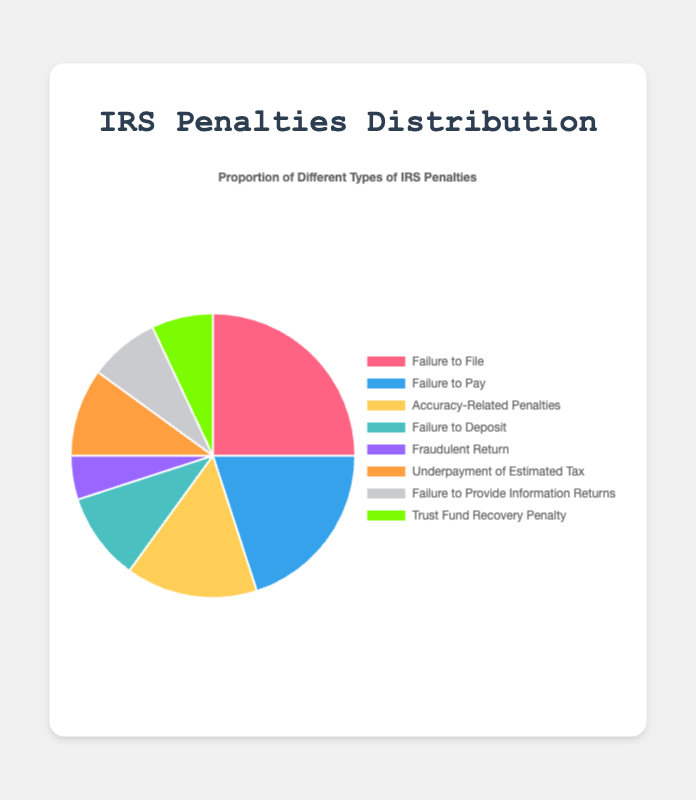Which penalty type has the highest proportion? The penalty type with the highest proportion can be identified as the largest segment in the pie chart. "Failure to File" has the highest proportion as its segment is 25% of the pie.
Answer: Failure to File Which penalty type has the smallest proportion? The penalty type with the smallest proportion is the one with the smallest segment in the pie chart. "Fraudulent Return" has the smallest proportion, making up only 5% of the pie.
Answer: Fraudulent Return What is the sum of the proportions of "Failure to Pay" and "Underpayment of Estimated Tax"? To get the sum, we add the proportions of "Failure to Pay" (20%) and "Underpayment of Estimated Tax" (10%). 20 + 10 = 30.
Answer: 30% How much greater is the proportion of "Failure to File" compared to "Failure to Deposit"? The difference between the proportions is calculated by subtracting the proportion of "Failure to Deposit" (10%) from "Failure to File" (25%). 25 - 10 = 15
Answer: 15% Which penalty types have equal proportions, and what are those proportions? By examining the chart, we see that "Failure to Deposit" and "Underpayment of Estimated Tax" both have slices representing 10%.
Answer: Failure to Deposit and Underpayment of Estimated Tax; 10% What is the combined proportion of the "Failure to Provide Information Returns" and "Trust Fund Recovery Penalty"? Add the proportions for these two categories: "Failure to Provide Information Returns" (8%) and "Trust Fund Recovery Penalty" (7%). 8 + 7 = 15
Answer: 15% What proportion of penalties is accounted for by the combination of "Accuracy-Related Penalties" and "Fraudulent Return"? Add up the proportions of "Accuracy-Related Penalties" (15%) and "Fraudulent Return" (5%). 15 + 5 = 20
Answer: 20% By how much does the proportion of "Trust Fund Recovery Penalty" differ from "Fraudulent Return"? The difference is found by subtracting the proportion of "Trust Fund Recovery Penalty" (7%) from "Fraudulent Return" (5%). 7 - 5 = 2
Answer: 2% What is the average proportion of all the penalty types? To find the average, sum all the proportions and divide by the number of categories: (25 + 20 + 15 + 10 + 5 + 10 + 8 + 7) / 8 = 100 / 8 = 12.5
Answer: 12.5% Which penalty type will you find in yellow, and what is its proportion? The chart specifies that "Accuracy-Related Penalties" is shown in yellow. It has a proportion of 15%.
Answer: Accuracy-Related Penalties; 15% 